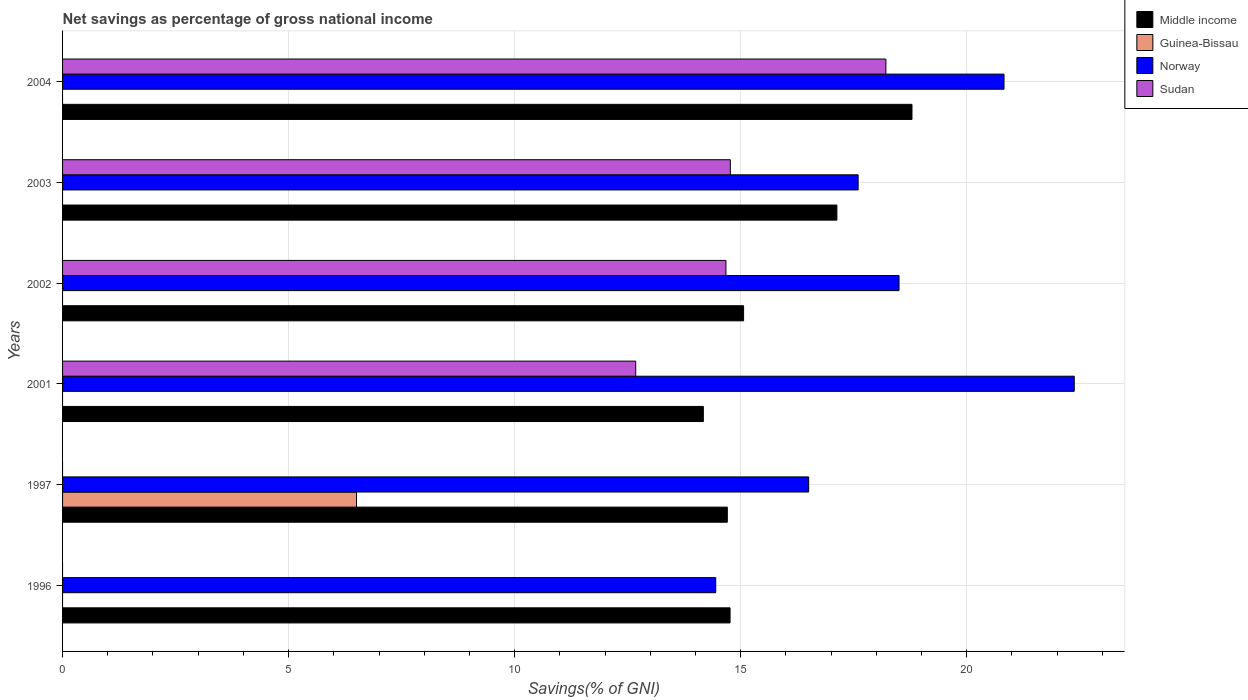How many groups of bars are there?
Provide a succinct answer. 6. How many bars are there on the 2nd tick from the top?
Your answer should be very brief. 3. How many bars are there on the 3rd tick from the bottom?
Offer a very short reply. 3. What is the label of the 3rd group of bars from the top?
Make the answer very short. 2002. In how many cases, is the number of bars for a given year not equal to the number of legend labels?
Keep it short and to the point. 6. What is the total savings in Middle income in 2002?
Give a very brief answer. 15.06. Across all years, what is the maximum total savings in Norway?
Your answer should be very brief. 22.38. Across all years, what is the minimum total savings in Norway?
Provide a succinct answer. 14.45. What is the total total savings in Norway in the graph?
Make the answer very short. 110.25. What is the difference between the total savings in Norway in 2002 and that in 2003?
Provide a short and direct response. 0.9. What is the difference between the total savings in Sudan in 2003 and the total savings in Middle income in 2002?
Your response must be concise. -0.29. What is the average total savings in Norway per year?
Give a very brief answer. 18.38. In the year 1997, what is the difference between the total savings in Guinea-Bissau and total savings in Middle income?
Your answer should be very brief. -8.2. In how many years, is the total savings in Middle income greater than 9 %?
Make the answer very short. 6. What is the ratio of the total savings in Middle income in 1997 to that in 2003?
Provide a succinct answer. 0.86. Is the total savings in Sudan in 2002 less than that in 2003?
Ensure brevity in your answer.  Yes. What is the difference between the highest and the second highest total savings in Middle income?
Your response must be concise. 1.66. What is the difference between the highest and the lowest total savings in Middle income?
Offer a terse response. 4.61. How many bars are there?
Offer a very short reply. 17. Does the graph contain any zero values?
Give a very brief answer. Yes. Where does the legend appear in the graph?
Your response must be concise. Top right. How are the legend labels stacked?
Keep it short and to the point. Vertical. What is the title of the graph?
Ensure brevity in your answer.  Net savings as percentage of gross national income. Does "Heavily indebted poor countries" appear as one of the legend labels in the graph?
Provide a short and direct response. No. What is the label or title of the X-axis?
Your answer should be very brief. Savings(% of GNI). What is the label or title of the Y-axis?
Offer a very short reply. Years. What is the Savings(% of GNI) of Middle income in 1996?
Your answer should be compact. 14.76. What is the Savings(% of GNI) in Guinea-Bissau in 1996?
Your response must be concise. 0. What is the Savings(% of GNI) of Norway in 1996?
Your response must be concise. 14.45. What is the Savings(% of GNI) of Sudan in 1996?
Provide a short and direct response. 0. What is the Savings(% of GNI) of Middle income in 1997?
Make the answer very short. 14.7. What is the Savings(% of GNI) of Guinea-Bissau in 1997?
Make the answer very short. 6.5. What is the Savings(% of GNI) of Norway in 1997?
Offer a terse response. 16.5. What is the Savings(% of GNI) of Middle income in 2001?
Give a very brief answer. 14.17. What is the Savings(% of GNI) of Guinea-Bissau in 2001?
Provide a short and direct response. 0. What is the Savings(% of GNI) in Norway in 2001?
Provide a succinct answer. 22.38. What is the Savings(% of GNI) of Sudan in 2001?
Offer a very short reply. 12.68. What is the Savings(% of GNI) in Middle income in 2002?
Keep it short and to the point. 15.06. What is the Savings(% of GNI) in Norway in 2002?
Your answer should be very brief. 18.5. What is the Savings(% of GNI) in Sudan in 2002?
Offer a terse response. 14.67. What is the Savings(% of GNI) of Middle income in 2003?
Offer a terse response. 17.13. What is the Savings(% of GNI) of Norway in 2003?
Offer a very short reply. 17.6. What is the Savings(% of GNI) of Sudan in 2003?
Keep it short and to the point. 14.77. What is the Savings(% of GNI) in Middle income in 2004?
Your answer should be compact. 18.79. What is the Savings(% of GNI) in Norway in 2004?
Offer a terse response. 20.82. What is the Savings(% of GNI) of Sudan in 2004?
Offer a terse response. 18.21. Across all years, what is the maximum Savings(% of GNI) in Middle income?
Give a very brief answer. 18.79. Across all years, what is the maximum Savings(% of GNI) of Guinea-Bissau?
Offer a terse response. 6.5. Across all years, what is the maximum Savings(% of GNI) in Norway?
Ensure brevity in your answer.  22.38. Across all years, what is the maximum Savings(% of GNI) of Sudan?
Your answer should be very brief. 18.21. Across all years, what is the minimum Savings(% of GNI) of Middle income?
Your answer should be compact. 14.17. Across all years, what is the minimum Savings(% of GNI) of Norway?
Your answer should be very brief. 14.45. What is the total Savings(% of GNI) in Middle income in the graph?
Your response must be concise. 94.62. What is the total Savings(% of GNI) of Guinea-Bissau in the graph?
Give a very brief answer. 6.5. What is the total Savings(% of GNI) in Norway in the graph?
Your answer should be compact. 110.25. What is the total Savings(% of GNI) of Sudan in the graph?
Give a very brief answer. 60.33. What is the difference between the Savings(% of GNI) of Middle income in 1996 and that in 1997?
Your answer should be very brief. 0.06. What is the difference between the Savings(% of GNI) in Norway in 1996 and that in 1997?
Offer a terse response. -2.06. What is the difference between the Savings(% of GNI) in Middle income in 1996 and that in 2001?
Provide a succinct answer. 0.59. What is the difference between the Savings(% of GNI) in Norway in 1996 and that in 2001?
Your answer should be compact. -7.93. What is the difference between the Savings(% of GNI) of Middle income in 1996 and that in 2002?
Give a very brief answer. -0.3. What is the difference between the Savings(% of GNI) of Norway in 1996 and that in 2002?
Give a very brief answer. -4.05. What is the difference between the Savings(% of GNI) in Middle income in 1996 and that in 2003?
Keep it short and to the point. -2.36. What is the difference between the Savings(% of GNI) of Norway in 1996 and that in 2003?
Provide a short and direct response. -3.15. What is the difference between the Savings(% of GNI) of Middle income in 1996 and that in 2004?
Offer a very short reply. -4.02. What is the difference between the Savings(% of GNI) in Norway in 1996 and that in 2004?
Keep it short and to the point. -6.38. What is the difference between the Savings(% of GNI) in Middle income in 1997 and that in 2001?
Offer a very short reply. 0.53. What is the difference between the Savings(% of GNI) of Norway in 1997 and that in 2001?
Ensure brevity in your answer.  -5.87. What is the difference between the Savings(% of GNI) in Middle income in 1997 and that in 2002?
Give a very brief answer. -0.36. What is the difference between the Savings(% of GNI) of Norway in 1997 and that in 2002?
Your response must be concise. -2. What is the difference between the Savings(% of GNI) of Middle income in 1997 and that in 2003?
Your answer should be compact. -2.42. What is the difference between the Savings(% of GNI) of Norway in 1997 and that in 2003?
Make the answer very short. -1.09. What is the difference between the Savings(% of GNI) in Middle income in 1997 and that in 2004?
Provide a succinct answer. -4.08. What is the difference between the Savings(% of GNI) of Norway in 1997 and that in 2004?
Provide a succinct answer. -4.32. What is the difference between the Savings(% of GNI) of Middle income in 2001 and that in 2002?
Your answer should be compact. -0.89. What is the difference between the Savings(% of GNI) of Norway in 2001 and that in 2002?
Your answer should be very brief. 3.88. What is the difference between the Savings(% of GNI) of Sudan in 2001 and that in 2002?
Make the answer very short. -2. What is the difference between the Savings(% of GNI) in Middle income in 2001 and that in 2003?
Offer a very short reply. -2.95. What is the difference between the Savings(% of GNI) of Norway in 2001 and that in 2003?
Offer a very short reply. 4.78. What is the difference between the Savings(% of GNI) of Sudan in 2001 and that in 2003?
Make the answer very short. -2.09. What is the difference between the Savings(% of GNI) of Middle income in 2001 and that in 2004?
Make the answer very short. -4.61. What is the difference between the Savings(% of GNI) of Norway in 2001 and that in 2004?
Offer a very short reply. 1.55. What is the difference between the Savings(% of GNI) in Sudan in 2001 and that in 2004?
Provide a short and direct response. -5.53. What is the difference between the Savings(% of GNI) in Middle income in 2002 and that in 2003?
Provide a succinct answer. -2.06. What is the difference between the Savings(% of GNI) of Norway in 2002 and that in 2003?
Your answer should be very brief. 0.9. What is the difference between the Savings(% of GNI) in Sudan in 2002 and that in 2003?
Make the answer very short. -0.1. What is the difference between the Savings(% of GNI) in Middle income in 2002 and that in 2004?
Your response must be concise. -3.72. What is the difference between the Savings(% of GNI) in Norway in 2002 and that in 2004?
Provide a short and direct response. -2.32. What is the difference between the Savings(% of GNI) in Sudan in 2002 and that in 2004?
Keep it short and to the point. -3.54. What is the difference between the Savings(% of GNI) of Middle income in 2003 and that in 2004?
Make the answer very short. -1.66. What is the difference between the Savings(% of GNI) of Norway in 2003 and that in 2004?
Offer a very short reply. -3.23. What is the difference between the Savings(% of GNI) of Sudan in 2003 and that in 2004?
Offer a terse response. -3.44. What is the difference between the Savings(% of GNI) in Middle income in 1996 and the Savings(% of GNI) in Guinea-Bissau in 1997?
Give a very brief answer. 8.26. What is the difference between the Savings(% of GNI) in Middle income in 1996 and the Savings(% of GNI) in Norway in 1997?
Offer a terse response. -1.74. What is the difference between the Savings(% of GNI) in Middle income in 1996 and the Savings(% of GNI) in Norway in 2001?
Provide a succinct answer. -7.61. What is the difference between the Savings(% of GNI) of Middle income in 1996 and the Savings(% of GNI) of Sudan in 2001?
Give a very brief answer. 2.09. What is the difference between the Savings(% of GNI) of Norway in 1996 and the Savings(% of GNI) of Sudan in 2001?
Offer a very short reply. 1.77. What is the difference between the Savings(% of GNI) in Middle income in 1996 and the Savings(% of GNI) in Norway in 2002?
Provide a short and direct response. -3.74. What is the difference between the Savings(% of GNI) in Middle income in 1996 and the Savings(% of GNI) in Sudan in 2002?
Offer a terse response. 0.09. What is the difference between the Savings(% of GNI) of Norway in 1996 and the Savings(% of GNI) of Sudan in 2002?
Provide a succinct answer. -0.23. What is the difference between the Savings(% of GNI) in Middle income in 1996 and the Savings(% of GNI) in Norway in 2003?
Ensure brevity in your answer.  -2.83. What is the difference between the Savings(% of GNI) in Middle income in 1996 and the Savings(% of GNI) in Sudan in 2003?
Provide a succinct answer. -0.01. What is the difference between the Savings(% of GNI) of Norway in 1996 and the Savings(% of GNI) of Sudan in 2003?
Make the answer very short. -0.32. What is the difference between the Savings(% of GNI) in Middle income in 1996 and the Savings(% of GNI) in Norway in 2004?
Keep it short and to the point. -6.06. What is the difference between the Savings(% of GNI) in Middle income in 1996 and the Savings(% of GNI) in Sudan in 2004?
Keep it short and to the point. -3.45. What is the difference between the Savings(% of GNI) of Norway in 1996 and the Savings(% of GNI) of Sudan in 2004?
Provide a succinct answer. -3.76. What is the difference between the Savings(% of GNI) of Middle income in 1997 and the Savings(% of GNI) of Norway in 2001?
Ensure brevity in your answer.  -7.67. What is the difference between the Savings(% of GNI) of Middle income in 1997 and the Savings(% of GNI) of Sudan in 2001?
Make the answer very short. 2.03. What is the difference between the Savings(% of GNI) of Guinea-Bissau in 1997 and the Savings(% of GNI) of Norway in 2001?
Your answer should be very brief. -15.88. What is the difference between the Savings(% of GNI) of Guinea-Bissau in 1997 and the Savings(% of GNI) of Sudan in 2001?
Provide a short and direct response. -6.18. What is the difference between the Savings(% of GNI) in Norway in 1997 and the Savings(% of GNI) in Sudan in 2001?
Make the answer very short. 3.83. What is the difference between the Savings(% of GNI) in Middle income in 1997 and the Savings(% of GNI) in Norway in 2002?
Provide a short and direct response. -3.8. What is the difference between the Savings(% of GNI) in Middle income in 1997 and the Savings(% of GNI) in Sudan in 2002?
Make the answer very short. 0.03. What is the difference between the Savings(% of GNI) of Guinea-Bissau in 1997 and the Savings(% of GNI) of Norway in 2002?
Offer a very short reply. -12. What is the difference between the Savings(% of GNI) of Guinea-Bissau in 1997 and the Savings(% of GNI) of Sudan in 2002?
Your response must be concise. -8.17. What is the difference between the Savings(% of GNI) in Norway in 1997 and the Savings(% of GNI) in Sudan in 2002?
Your response must be concise. 1.83. What is the difference between the Savings(% of GNI) in Middle income in 1997 and the Savings(% of GNI) in Norway in 2003?
Ensure brevity in your answer.  -2.89. What is the difference between the Savings(% of GNI) of Middle income in 1997 and the Savings(% of GNI) of Sudan in 2003?
Your answer should be compact. -0.07. What is the difference between the Savings(% of GNI) of Guinea-Bissau in 1997 and the Savings(% of GNI) of Norway in 2003?
Provide a short and direct response. -11.1. What is the difference between the Savings(% of GNI) in Guinea-Bissau in 1997 and the Savings(% of GNI) in Sudan in 2003?
Offer a terse response. -8.27. What is the difference between the Savings(% of GNI) in Norway in 1997 and the Savings(% of GNI) in Sudan in 2003?
Provide a short and direct response. 1.73. What is the difference between the Savings(% of GNI) of Middle income in 1997 and the Savings(% of GNI) of Norway in 2004?
Your answer should be very brief. -6.12. What is the difference between the Savings(% of GNI) in Middle income in 1997 and the Savings(% of GNI) in Sudan in 2004?
Keep it short and to the point. -3.51. What is the difference between the Savings(% of GNI) in Guinea-Bissau in 1997 and the Savings(% of GNI) in Norway in 2004?
Your answer should be compact. -14.32. What is the difference between the Savings(% of GNI) of Guinea-Bissau in 1997 and the Savings(% of GNI) of Sudan in 2004?
Provide a short and direct response. -11.71. What is the difference between the Savings(% of GNI) of Norway in 1997 and the Savings(% of GNI) of Sudan in 2004?
Keep it short and to the point. -1.71. What is the difference between the Savings(% of GNI) of Middle income in 2001 and the Savings(% of GNI) of Norway in 2002?
Your response must be concise. -4.33. What is the difference between the Savings(% of GNI) of Middle income in 2001 and the Savings(% of GNI) of Sudan in 2002?
Provide a short and direct response. -0.5. What is the difference between the Savings(% of GNI) in Norway in 2001 and the Savings(% of GNI) in Sudan in 2002?
Provide a short and direct response. 7.7. What is the difference between the Savings(% of GNI) in Middle income in 2001 and the Savings(% of GNI) in Norway in 2003?
Your response must be concise. -3.42. What is the difference between the Savings(% of GNI) in Middle income in 2001 and the Savings(% of GNI) in Sudan in 2003?
Your answer should be compact. -0.6. What is the difference between the Savings(% of GNI) of Norway in 2001 and the Savings(% of GNI) of Sudan in 2003?
Your answer should be very brief. 7.61. What is the difference between the Savings(% of GNI) of Middle income in 2001 and the Savings(% of GNI) of Norway in 2004?
Your answer should be very brief. -6.65. What is the difference between the Savings(% of GNI) of Middle income in 2001 and the Savings(% of GNI) of Sudan in 2004?
Offer a terse response. -4.04. What is the difference between the Savings(% of GNI) in Norway in 2001 and the Savings(% of GNI) in Sudan in 2004?
Keep it short and to the point. 4.17. What is the difference between the Savings(% of GNI) of Middle income in 2002 and the Savings(% of GNI) of Norway in 2003?
Offer a very short reply. -2.53. What is the difference between the Savings(% of GNI) of Middle income in 2002 and the Savings(% of GNI) of Sudan in 2003?
Make the answer very short. 0.29. What is the difference between the Savings(% of GNI) of Norway in 2002 and the Savings(% of GNI) of Sudan in 2003?
Offer a terse response. 3.73. What is the difference between the Savings(% of GNI) in Middle income in 2002 and the Savings(% of GNI) in Norway in 2004?
Offer a very short reply. -5.76. What is the difference between the Savings(% of GNI) of Middle income in 2002 and the Savings(% of GNI) of Sudan in 2004?
Your answer should be very brief. -3.15. What is the difference between the Savings(% of GNI) of Norway in 2002 and the Savings(% of GNI) of Sudan in 2004?
Offer a terse response. 0.29. What is the difference between the Savings(% of GNI) of Middle income in 2003 and the Savings(% of GNI) of Norway in 2004?
Provide a short and direct response. -3.7. What is the difference between the Savings(% of GNI) of Middle income in 2003 and the Savings(% of GNI) of Sudan in 2004?
Provide a succinct answer. -1.08. What is the difference between the Savings(% of GNI) in Norway in 2003 and the Savings(% of GNI) in Sudan in 2004?
Your answer should be very brief. -0.61. What is the average Savings(% of GNI) in Middle income per year?
Your answer should be compact. 15.77. What is the average Savings(% of GNI) in Guinea-Bissau per year?
Your answer should be very brief. 1.08. What is the average Savings(% of GNI) of Norway per year?
Your response must be concise. 18.38. What is the average Savings(% of GNI) of Sudan per year?
Make the answer very short. 10.06. In the year 1996, what is the difference between the Savings(% of GNI) in Middle income and Savings(% of GNI) in Norway?
Provide a short and direct response. 0.32. In the year 1997, what is the difference between the Savings(% of GNI) in Middle income and Savings(% of GNI) in Guinea-Bissau?
Provide a succinct answer. 8.2. In the year 1997, what is the difference between the Savings(% of GNI) of Middle income and Savings(% of GNI) of Norway?
Your answer should be compact. -1.8. In the year 1997, what is the difference between the Savings(% of GNI) of Guinea-Bissau and Savings(% of GNI) of Norway?
Offer a terse response. -10. In the year 2001, what is the difference between the Savings(% of GNI) in Middle income and Savings(% of GNI) in Norway?
Keep it short and to the point. -8.2. In the year 2001, what is the difference between the Savings(% of GNI) of Middle income and Savings(% of GNI) of Sudan?
Your response must be concise. 1.5. In the year 2001, what is the difference between the Savings(% of GNI) in Norway and Savings(% of GNI) in Sudan?
Give a very brief answer. 9.7. In the year 2002, what is the difference between the Savings(% of GNI) of Middle income and Savings(% of GNI) of Norway?
Your response must be concise. -3.44. In the year 2002, what is the difference between the Savings(% of GNI) in Middle income and Savings(% of GNI) in Sudan?
Offer a terse response. 0.39. In the year 2002, what is the difference between the Savings(% of GNI) in Norway and Savings(% of GNI) in Sudan?
Keep it short and to the point. 3.83. In the year 2003, what is the difference between the Savings(% of GNI) of Middle income and Savings(% of GNI) of Norway?
Provide a short and direct response. -0.47. In the year 2003, what is the difference between the Savings(% of GNI) of Middle income and Savings(% of GNI) of Sudan?
Your response must be concise. 2.36. In the year 2003, what is the difference between the Savings(% of GNI) of Norway and Savings(% of GNI) of Sudan?
Your response must be concise. 2.83. In the year 2004, what is the difference between the Savings(% of GNI) in Middle income and Savings(% of GNI) in Norway?
Provide a short and direct response. -2.04. In the year 2004, what is the difference between the Savings(% of GNI) in Middle income and Savings(% of GNI) in Sudan?
Your answer should be compact. 0.58. In the year 2004, what is the difference between the Savings(% of GNI) in Norway and Savings(% of GNI) in Sudan?
Make the answer very short. 2.61. What is the ratio of the Savings(% of GNI) in Norway in 1996 to that in 1997?
Your answer should be very brief. 0.88. What is the ratio of the Savings(% of GNI) of Middle income in 1996 to that in 2001?
Keep it short and to the point. 1.04. What is the ratio of the Savings(% of GNI) of Norway in 1996 to that in 2001?
Provide a succinct answer. 0.65. What is the ratio of the Savings(% of GNI) in Middle income in 1996 to that in 2002?
Ensure brevity in your answer.  0.98. What is the ratio of the Savings(% of GNI) of Norway in 1996 to that in 2002?
Make the answer very short. 0.78. What is the ratio of the Savings(% of GNI) of Middle income in 1996 to that in 2003?
Give a very brief answer. 0.86. What is the ratio of the Savings(% of GNI) of Norway in 1996 to that in 2003?
Offer a very short reply. 0.82. What is the ratio of the Savings(% of GNI) in Middle income in 1996 to that in 2004?
Keep it short and to the point. 0.79. What is the ratio of the Savings(% of GNI) in Norway in 1996 to that in 2004?
Ensure brevity in your answer.  0.69. What is the ratio of the Savings(% of GNI) in Middle income in 1997 to that in 2001?
Ensure brevity in your answer.  1.04. What is the ratio of the Savings(% of GNI) of Norway in 1997 to that in 2001?
Keep it short and to the point. 0.74. What is the ratio of the Savings(% of GNI) in Middle income in 1997 to that in 2002?
Your answer should be compact. 0.98. What is the ratio of the Savings(% of GNI) in Norway in 1997 to that in 2002?
Provide a succinct answer. 0.89. What is the ratio of the Savings(% of GNI) of Middle income in 1997 to that in 2003?
Your answer should be compact. 0.86. What is the ratio of the Savings(% of GNI) in Norway in 1997 to that in 2003?
Offer a terse response. 0.94. What is the ratio of the Savings(% of GNI) of Middle income in 1997 to that in 2004?
Make the answer very short. 0.78. What is the ratio of the Savings(% of GNI) of Norway in 1997 to that in 2004?
Give a very brief answer. 0.79. What is the ratio of the Savings(% of GNI) of Middle income in 2001 to that in 2002?
Your answer should be very brief. 0.94. What is the ratio of the Savings(% of GNI) in Norway in 2001 to that in 2002?
Provide a short and direct response. 1.21. What is the ratio of the Savings(% of GNI) in Sudan in 2001 to that in 2002?
Keep it short and to the point. 0.86. What is the ratio of the Savings(% of GNI) in Middle income in 2001 to that in 2003?
Offer a very short reply. 0.83. What is the ratio of the Savings(% of GNI) of Norway in 2001 to that in 2003?
Offer a terse response. 1.27. What is the ratio of the Savings(% of GNI) in Sudan in 2001 to that in 2003?
Ensure brevity in your answer.  0.86. What is the ratio of the Savings(% of GNI) of Middle income in 2001 to that in 2004?
Your answer should be compact. 0.75. What is the ratio of the Savings(% of GNI) of Norway in 2001 to that in 2004?
Your answer should be very brief. 1.07. What is the ratio of the Savings(% of GNI) in Sudan in 2001 to that in 2004?
Provide a short and direct response. 0.7. What is the ratio of the Savings(% of GNI) in Middle income in 2002 to that in 2003?
Provide a short and direct response. 0.88. What is the ratio of the Savings(% of GNI) of Norway in 2002 to that in 2003?
Your answer should be compact. 1.05. What is the ratio of the Savings(% of GNI) of Sudan in 2002 to that in 2003?
Your response must be concise. 0.99. What is the ratio of the Savings(% of GNI) in Middle income in 2002 to that in 2004?
Your answer should be very brief. 0.8. What is the ratio of the Savings(% of GNI) of Norway in 2002 to that in 2004?
Your answer should be compact. 0.89. What is the ratio of the Savings(% of GNI) in Sudan in 2002 to that in 2004?
Ensure brevity in your answer.  0.81. What is the ratio of the Savings(% of GNI) of Middle income in 2003 to that in 2004?
Give a very brief answer. 0.91. What is the ratio of the Savings(% of GNI) of Norway in 2003 to that in 2004?
Ensure brevity in your answer.  0.85. What is the ratio of the Savings(% of GNI) of Sudan in 2003 to that in 2004?
Give a very brief answer. 0.81. What is the difference between the highest and the second highest Savings(% of GNI) in Middle income?
Make the answer very short. 1.66. What is the difference between the highest and the second highest Savings(% of GNI) of Norway?
Ensure brevity in your answer.  1.55. What is the difference between the highest and the second highest Savings(% of GNI) of Sudan?
Make the answer very short. 3.44. What is the difference between the highest and the lowest Savings(% of GNI) of Middle income?
Your response must be concise. 4.61. What is the difference between the highest and the lowest Savings(% of GNI) in Guinea-Bissau?
Make the answer very short. 6.5. What is the difference between the highest and the lowest Savings(% of GNI) of Norway?
Offer a terse response. 7.93. What is the difference between the highest and the lowest Savings(% of GNI) in Sudan?
Give a very brief answer. 18.21. 